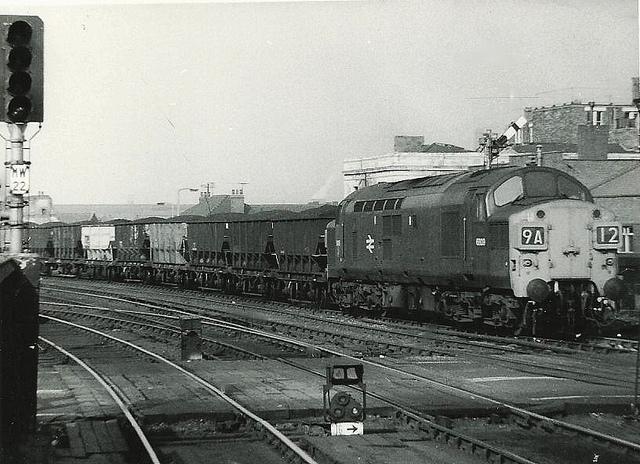What numbers are on the train?
Keep it brief. 9a 12. What is producing smoke in the background?
Keep it brief. Factory. What modes of transportation is visible?
Keep it brief. Train. Is the picture in color?
Write a very short answer. No. 